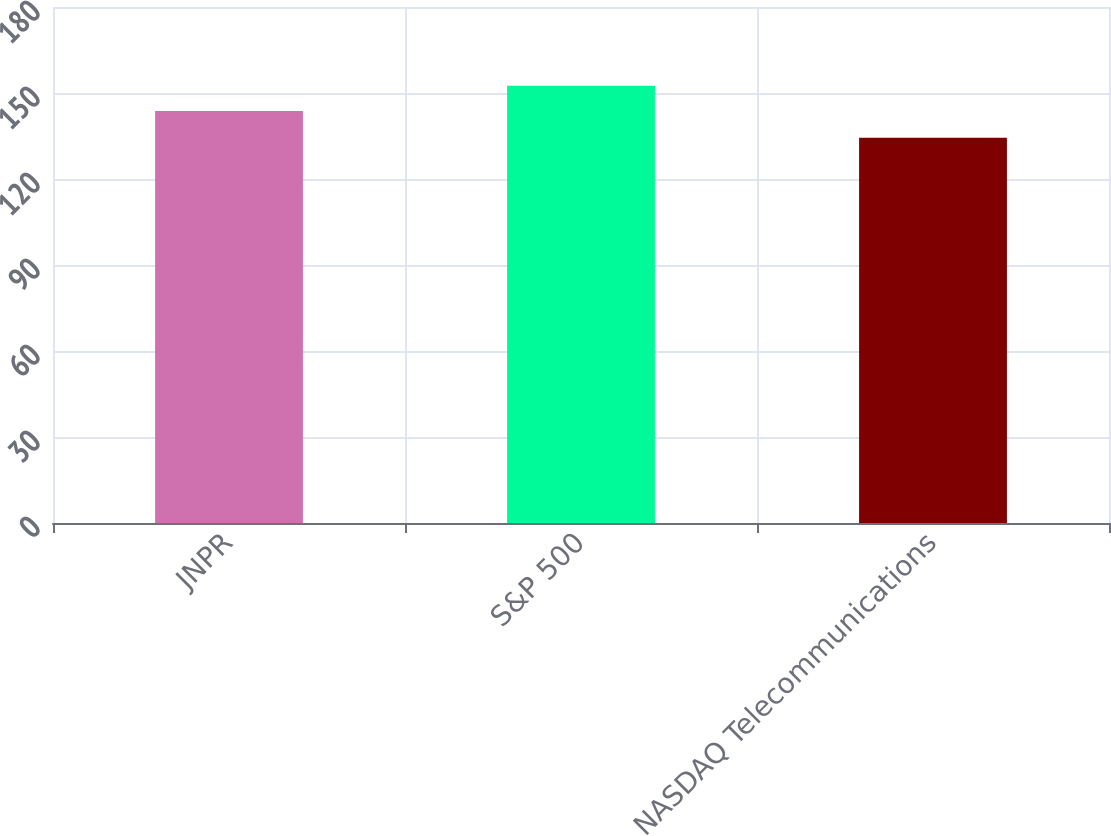<chart> <loc_0><loc_0><loc_500><loc_500><bar_chart><fcel>JNPR<fcel>S&P 500<fcel>NASDAQ Telecommunications<nl><fcel>143.68<fcel>152.55<fcel>134.42<nl></chart> 